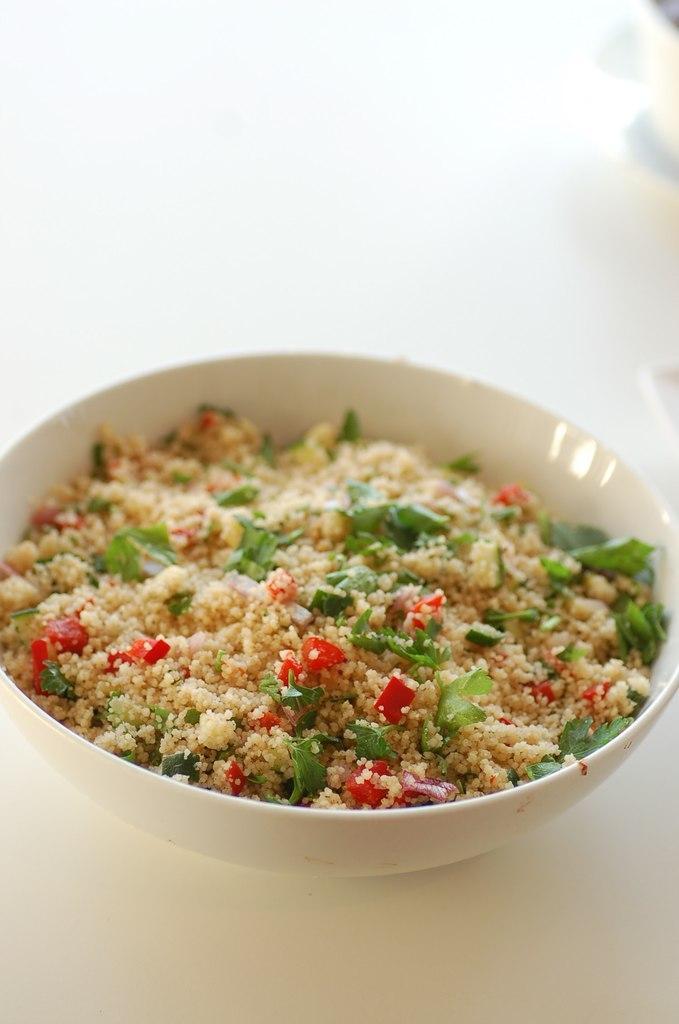How would you summarize this image in a sentence or two? In this image I can see the white colored surface and on it I can see a bowl which is white in color. In the bowl I can see some food item which is cream, green and red in color 